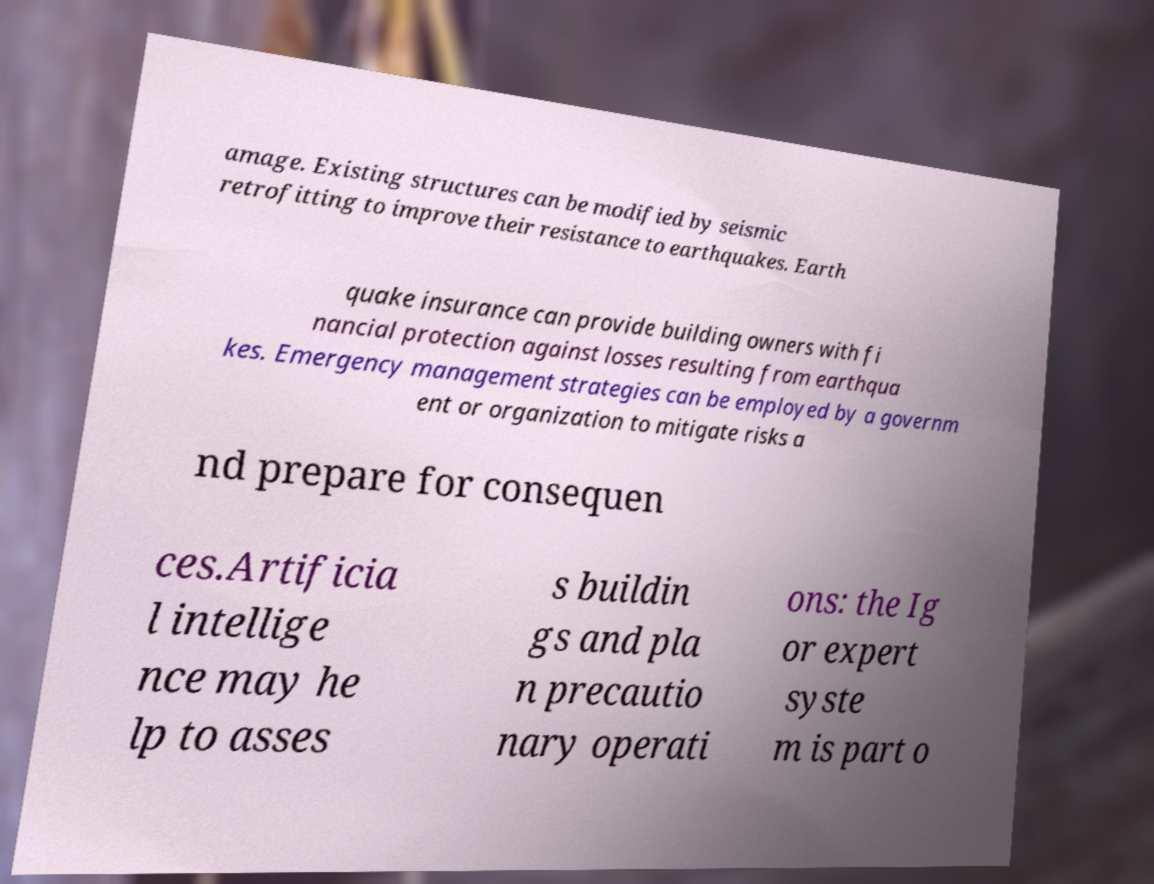Could you extract and type out the text from this image? amage. Existing structures can be modified by seismic retrofitting to improve their resistance to earthquakes. Earth quake insurance can provide building owners with fi nancial protection against losses resulting from earthqua kes. Emergency management strategies can be employed by a governm ent or organization to mitigate risks a nd prepare for consequen ces.Artificia l intellige nce may he lp to asses s buildin gs and pla n precautio nary operati ons: the Ig or expert syste m is part o 